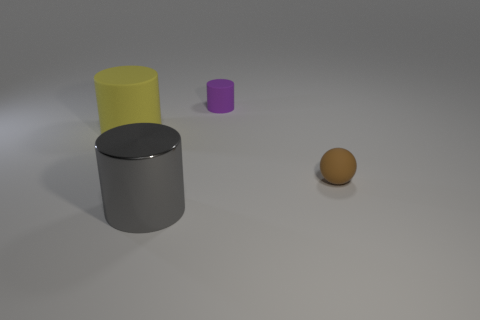What number of other things are the same color as the small matte cylinder?
Provide a short and direct response. 0. What is the gray cylinder made of?
Offer a terse response. Metal. What number of other objects are the same material as the gray cylinder?
Ensure brevity in your answer.  0. What is the size of the cylinder that is both left of the tiny purple matte cylinder and right of the big yellow rubber thing?
Offer a terse response. Large. There is a large object that is behind the big cylinder in front of the yellow rubber cylinder; what shape is it?
Your response must be concise. Cylinder. Is there anything else that is the same shape as the tiny brown rubber object?
Provide a succinct answer. No. Are there an equal number of big gray objects to the right of the small purple matte object and small purple things?
Offer a very short reply. No. Do the metallic cylinder and the tiny object that is in front of the large yellow rubber object have the same color?
Offer a terse response. No. What color is the thing that is both to the right of the shiny cylinder and in front of the tiny cylinder?
Provide a short and direct response. Brown. There is a big object behind the sphere; what number of big gray cylinders are on the left side of it?
Provide a succinct answer. 0. 